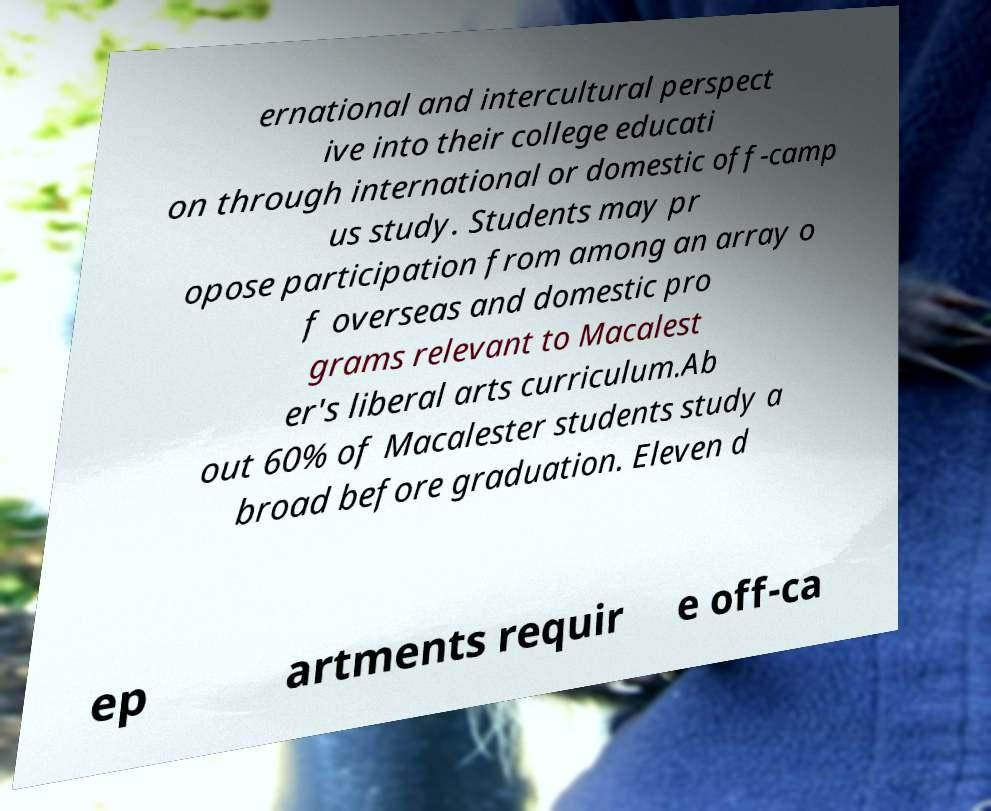Please read and relay the text visible in this image. What does it say? ernational and intercultural perspect ive into their college educati on through international or domestic off-camp us study. Students may pr opose participation from among an array o f overseas and domestic pro grams relevant to Macalest er's liberal arts curriculum.Ab out 60% of Macalester students study a broad before graduation. Eleven d ep artments requir e off-ca 